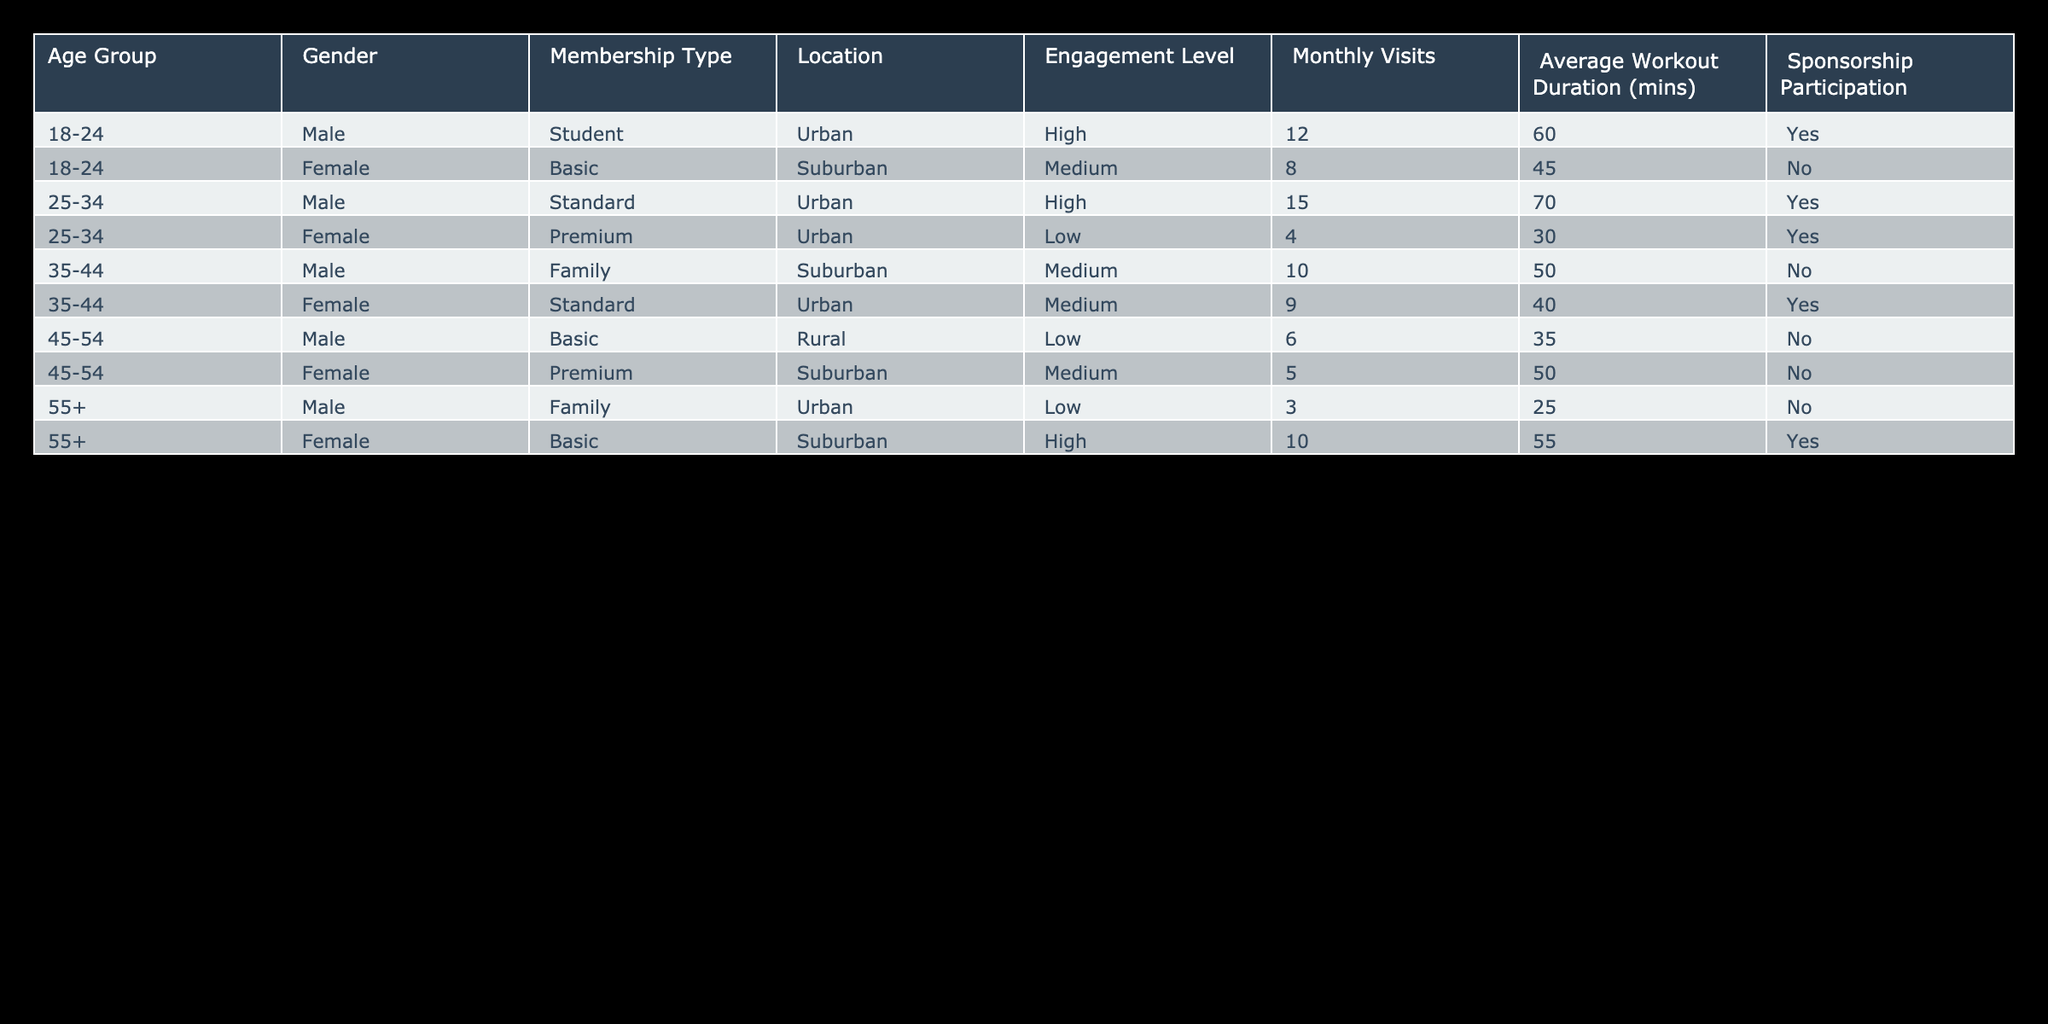What is the engagement level of male members in the 45-54 age group? There is one male member in the 45-54 age group with a Medium engagement level.
Answer: Medium How many times do female members in the 55+ age group visit the gym monthly on average? There is one female member in the 55+ age group who visits the gym 10 times monthly. Therefore, the average is 10 visits.
Answer: 10 What percentage of members with High engagement levels also participate in sponsorship? There are 4 members with High engagement levels (2 male in age group 18-24 and 1 female in 55+ age group, and 1 female in 25-34 age group), out of which 3 participate in sponsorship. So the percentage is (3/4) * 100 = 75%.
Answer: 75% Which membership type has the lowest average workout duration? The basic membership type has two corresponding members (male, age 45-54 with 35 mins and female 55+ with 55 mins). Therefore, the average workout duration is (35 + 55) / 2 = 45 mins.
Answer: 45 mins Is there a female member in the 25-34 age group with low engagement? Yes, there is one female member aged 25-34 with a Premium membership and Low engagement.
Answer: Yes How many total visits do urban members with High engagement levels make monthly? There are 3 urban members with High engagement (2 males aged 18-24 and 1 female aged 55+), with monthly visits of 12, 15, and 10 respectively. The total monthly visits are 12 + 15 + 10 = 37.
Answer: 37 What is the average age group for members that participate in sponsorship? The age groups of members that participate in sponsorship are 18-24 (2 males), 25-34 (1 male), and 55+ (1 female). The average age group can be calculated as (1*(18+24)/2) + (1*(25+34)/2)*1 + (1*(55))/1 =(21+29.5+55)/3 ≈ 35.17, which approximates to 35-44 age group.
Answer: 35-44 How many male members have a Family membership type? There are two male members with a Family membership type: one in the age group 35-44 and one in the age group 55+.
Answer: 2 